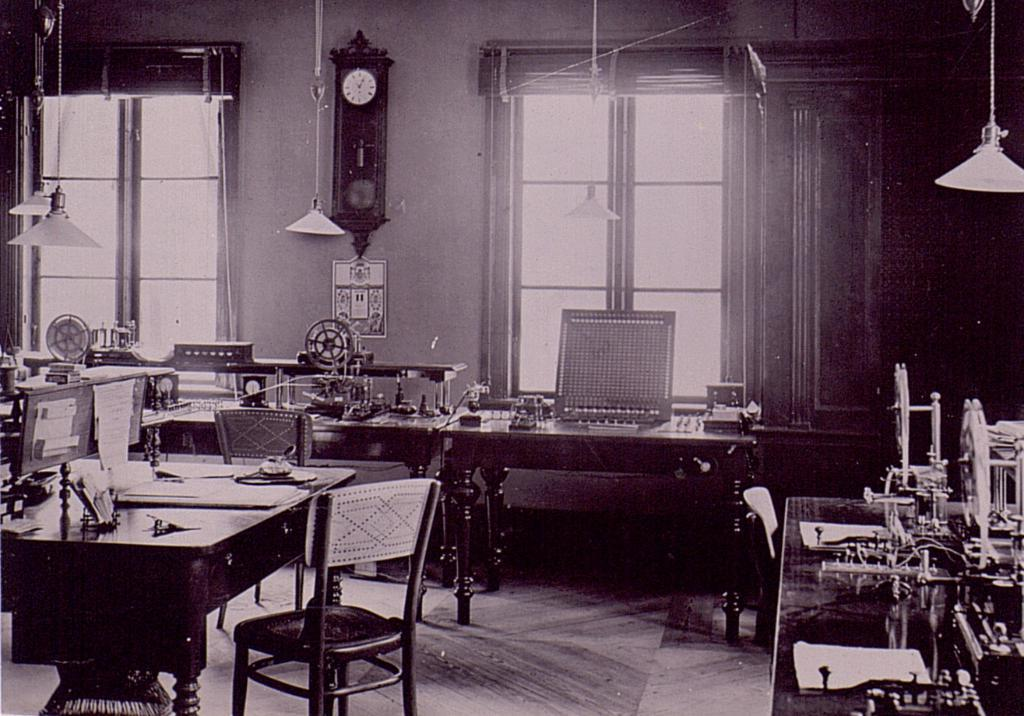What type of structure can be seen in the image? There is a wall in the image. What time-telling device is present in the image? There is a clock in the image. What allows natural light to enter the space in the image? There are windows in the image. What type of lighting is present in the image? Hanging lamps are present in the image. What type of furniture is present in the image? There are tables and chairs in the image. Can you describe any other objects in the image? There are a few other objects in the image. How many pigs are sitting on the chairs in the image? There are no pigs present in the image; it features a wall, a clock, windows, hanging lamps, tables, chairs, and a few other objects. What type of ant can be seen crawling on the clock in the image? There are no ants present in the image; it features a wall, a clock, windows, hanging lamps, tables, chairs, and a few other objects. 